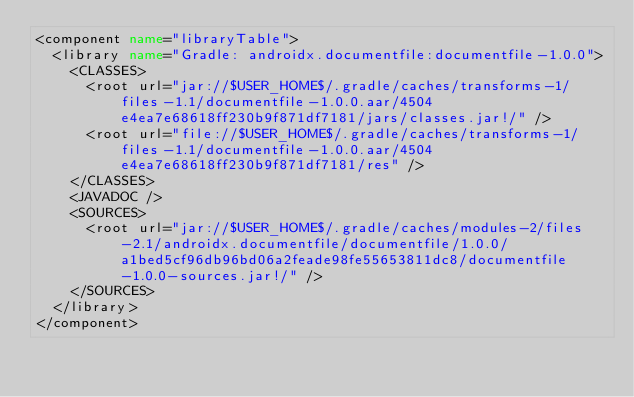<code> <loc_0><loc_0><loc_500><loc_500><_XML_><component name="libraryTable">
  <library name="Gradle: androidx.documentfile:documentfile-1.0.0">
    <CLASSES>
      <root url="jar://$USER_HOME$/.gradle/caches/transforms-1/files-1.1/documentfile-1.0.0.aar/4504e4ea7e68618ff230b9f871df7181/jars/classes.jar!/" />
      <root url="file://$USER_HOME$/.gradle/caches/transforms-1/files-1.1/documentfile-1.0.0.aar/4504e4ea7e68618ff230b9f871df7181/res" />
    </CLASSES>
    <JAVADOC />
    <SOURCES>
      <root url="jar://$USER_HOME$/.gradle/caches/modules-2/files-2.1/androidx.documentfile/documentfile/1.0.0/a1bed5cf96db96bd06a2feade98fe55653811dc8/documentfile-1.0.0-sources.jar!/" />
    </SOURCES>
  </library>
</component></code> 